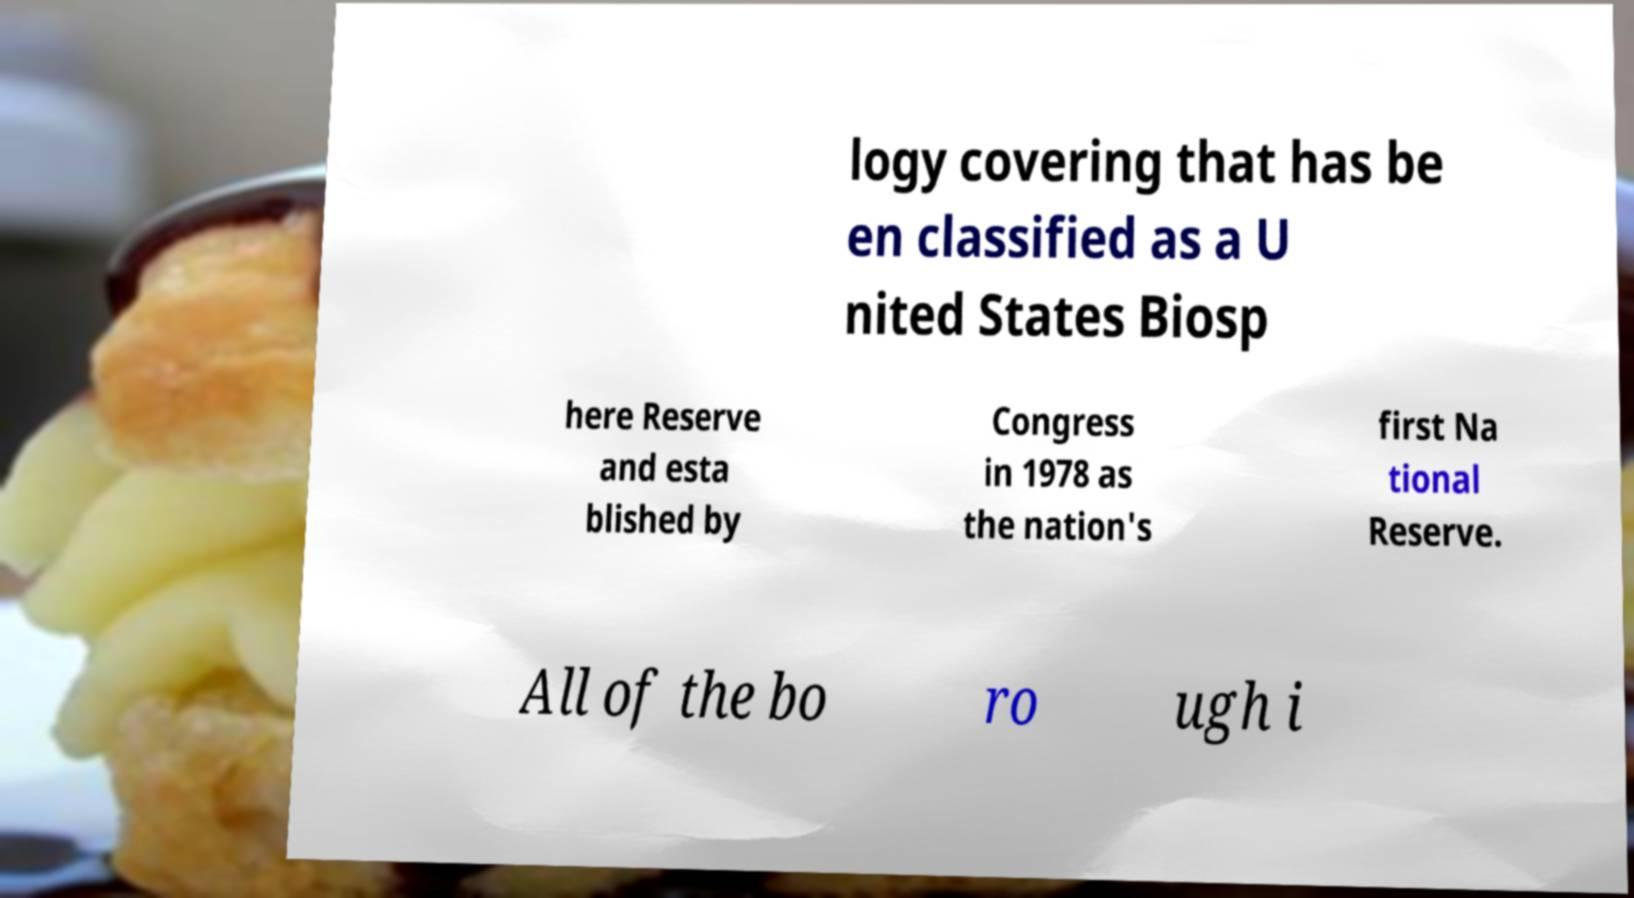Could you extract and type out the text from this image? logy covering that has be en classified as a U nited States Biosp here Reserve and esta blished by Congress in 1978 as the nation's first Na tional Reserve. All of the bo ro ugh i 